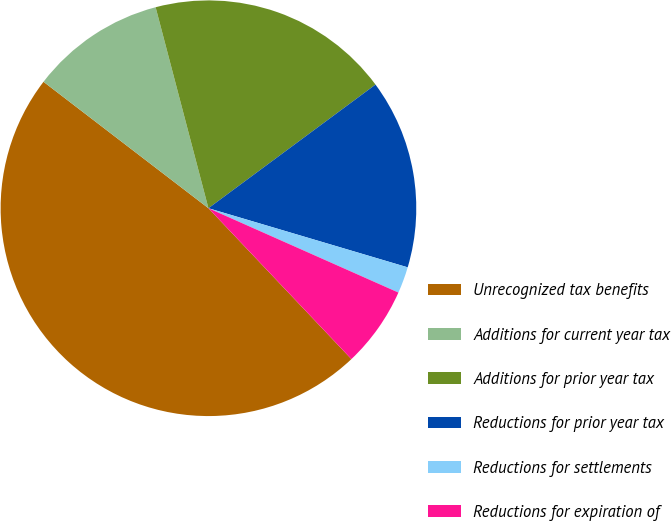Convert chart to OTSL. <chart><loc_0><loc_0><loc_500><loc_500><pie_chart><fcel>Unrecognized tax benefits<fcel>Additions for current year tax<fcel>Additions for prior year tax<fcel>Reductions for prior year tax<fcel>Reductions for settlements<fcel>Reductions for expiration of<nl><fcel>47.48%<fcel>10.5%<fcel>18.95%<fcel>14.73%<fcel>2.06%<fcel>6.28%<nl></chart> 